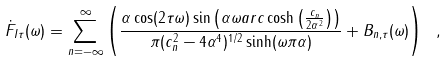Convert formula to latex. <formula><loc_0><loc_0><loc_500><loc_500>\dot { F } _ { I \tau } ( \omega ) = \sum _ { n = - \infty } ^ { \infty } \left ( \frac { \alpha \cos ( 2 \tau \omega ) \sin \left ( \alpha \omega { a r c \cosh \left ( \frac { c _ { n } } { 2 \alpha ^ { 2 } } \right ) } \right ) } { \pi ( c _ { n } ^ { 2 } - 4 \alpha ^ { 4 } ) ^ { 1 / 2 } \sinh ( \omega \pi \alpha ) } + B _ { n , \tau } ( \omega ) \right ) \ ,</formula> 